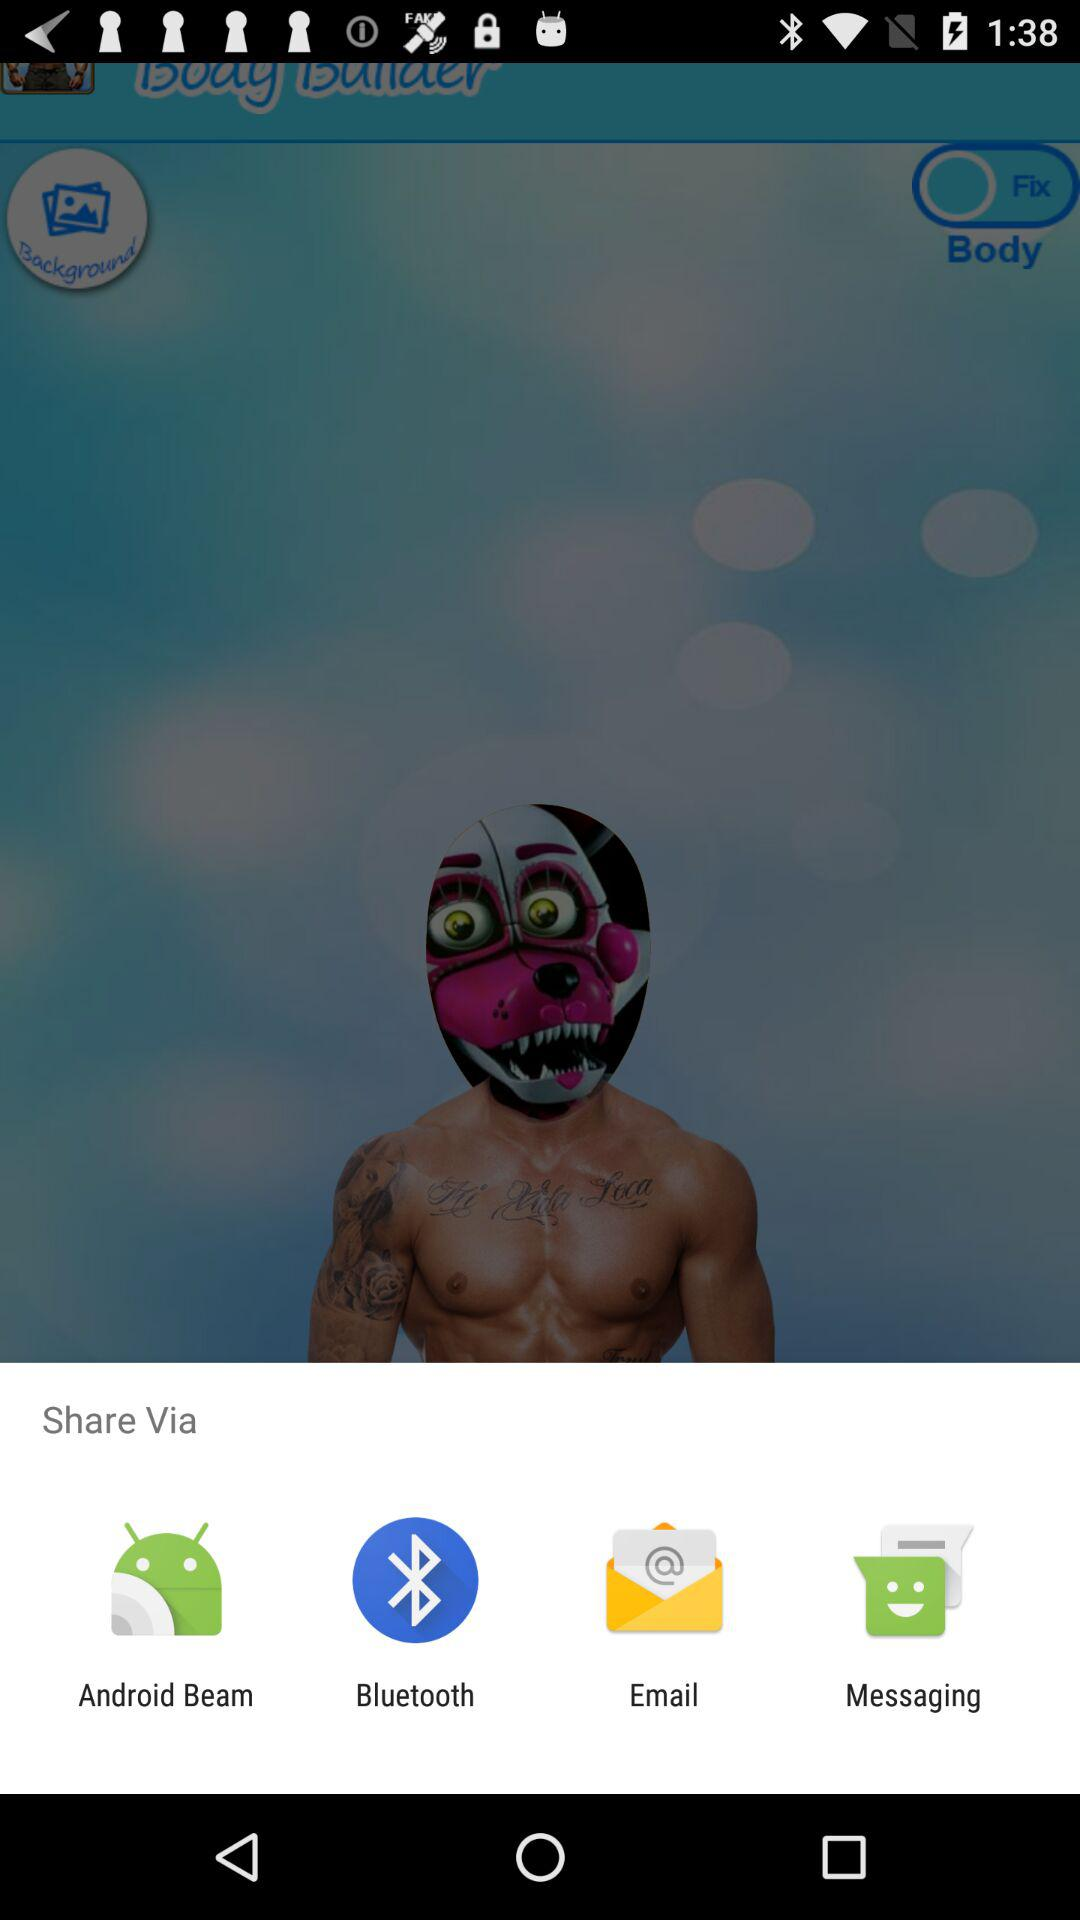How many share via options are there?
Answer the question using a single word or phrase. 4 